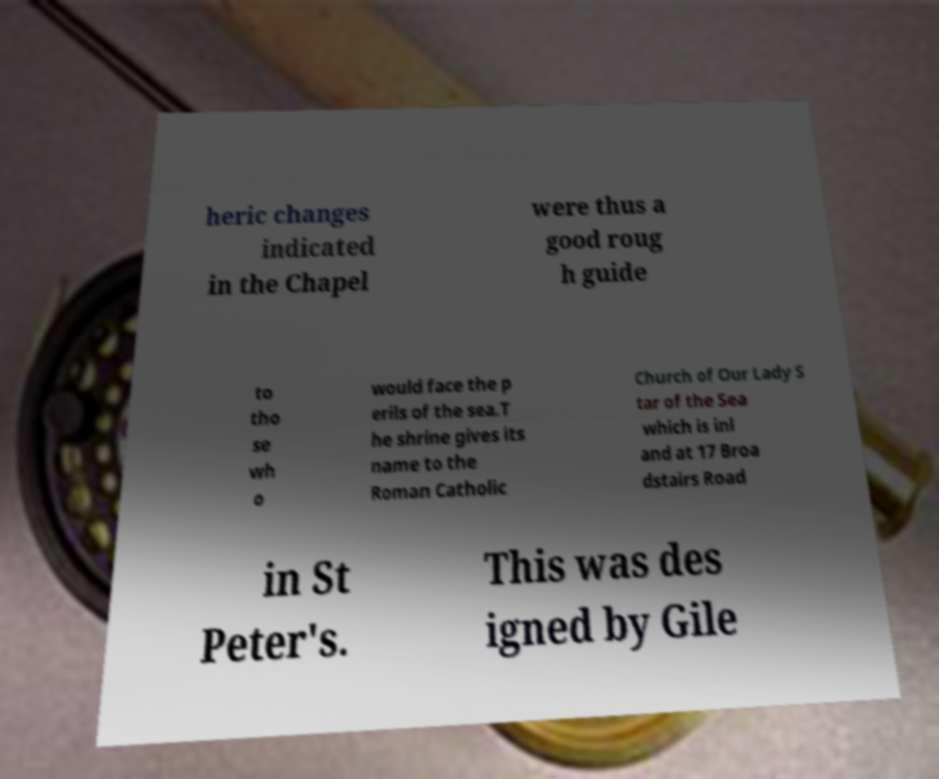Please read and relay the text visible in this image. What does it say? heric changes indicated in the Chapel were thus a good roug h guide to tho se wh o would face the p erils of the sea.T he shrine gives its name to the Roman Catholic Church of Our Lady S tar of the Sea which is inl and at 17 Broa dstairs Road in St Peter's. This was des igned by Gile 